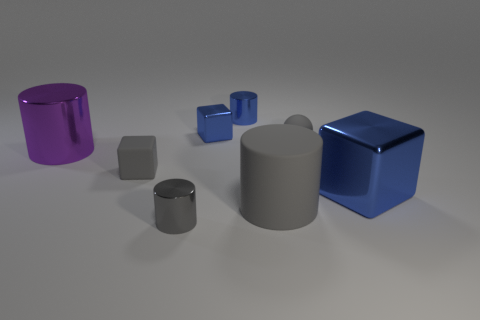Is there any other thing that is the same size as the blue shiny cylinder?
Offer a very short reply. Yes. Does the gray rubber ball have the same size as the gray block?
Ensure brevity in your answer.  Yes. The rubber cube has what color?
Ensure brevity in your answer.  Gray. What number of objects are either big blue cubes or big gray metal cubes?
Make the answer very short. 1. Is there a tiny blue metal thing that has the same shape as the large purple thing?
Offer a very short reply. Yes. Is the color of the metal cylinder that is to the right of the small metallic block the same as the large metal block?
Ensure brevity in your answer.  Yes. What shape is the large metal thing that is behind the big blue object behind the gray metallic object?
Ensure brevity in your answer.  Cylinder. Is there a thing of the same size as the gray metallic cylinder?
Your response must be concise. Yes. Is the number of big things less than the number of tiny gray rubber things?
Ensure brevity in your answer.  No. What is the shape of the blue metallic object on the right side of the tiny gray thing that is to the right of the small gray object in front of the tiny matte cube?
Make the answer very short. Cube. 